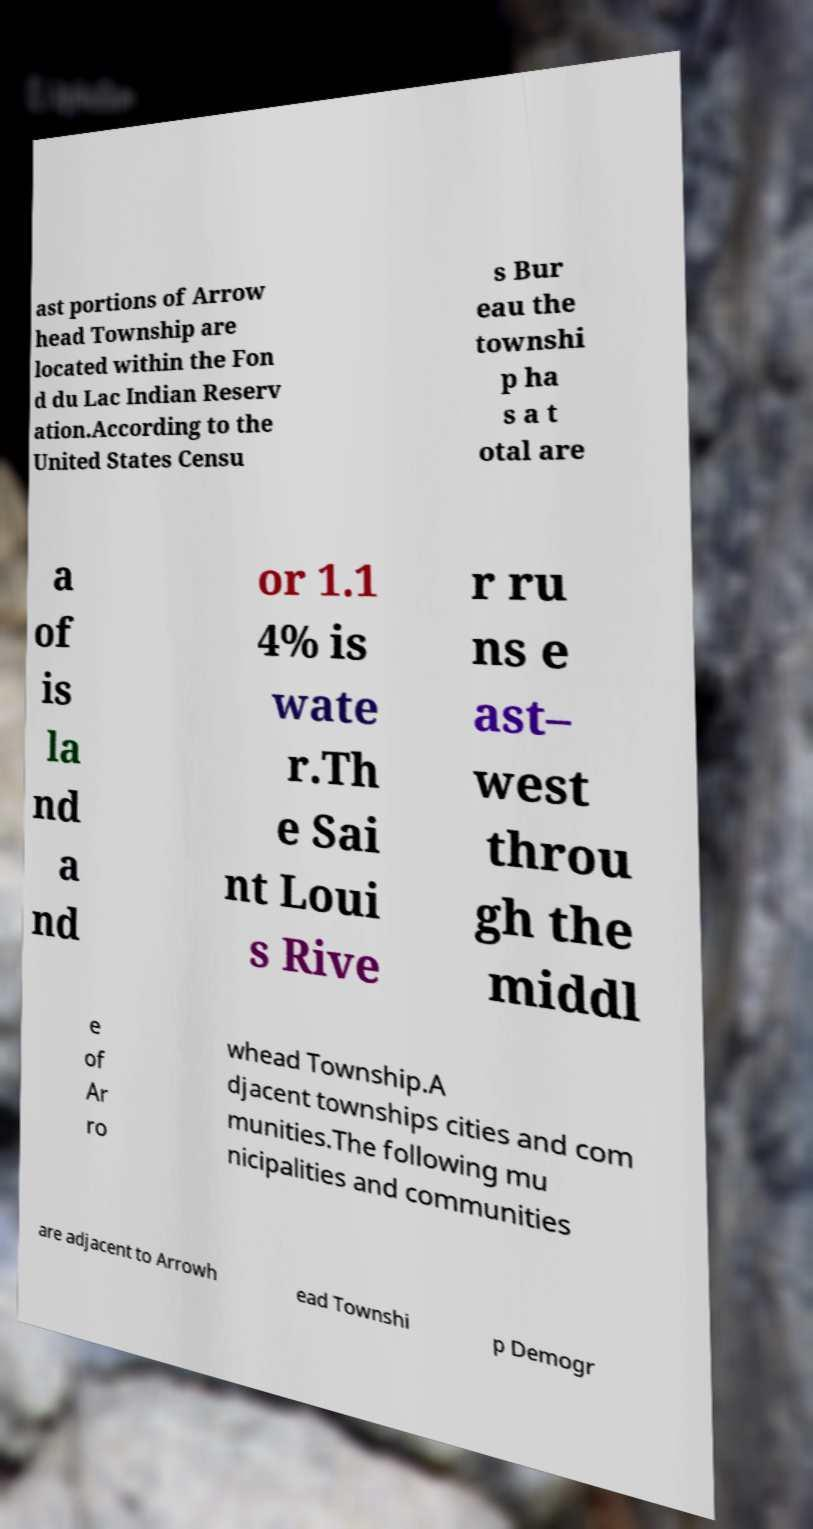Please read and relay the text visible in this image. What does it say? ast portions of Arrow head Township are located within the Fon d du Lac Indian Reserv ation.According to the United States Censu s Bur eau the townshi p ha s a t otal are a of is la nd a nd or 1.1 4% is wate r.Th e Sai nt Loui s Rive r ru ns e ast– west throu gh the middl e of Ar ro whead Township.A djacent townships cities and com munities.The following mu nicipalities and communities are adjacent to Arrowh ead Townshi p Demogr 